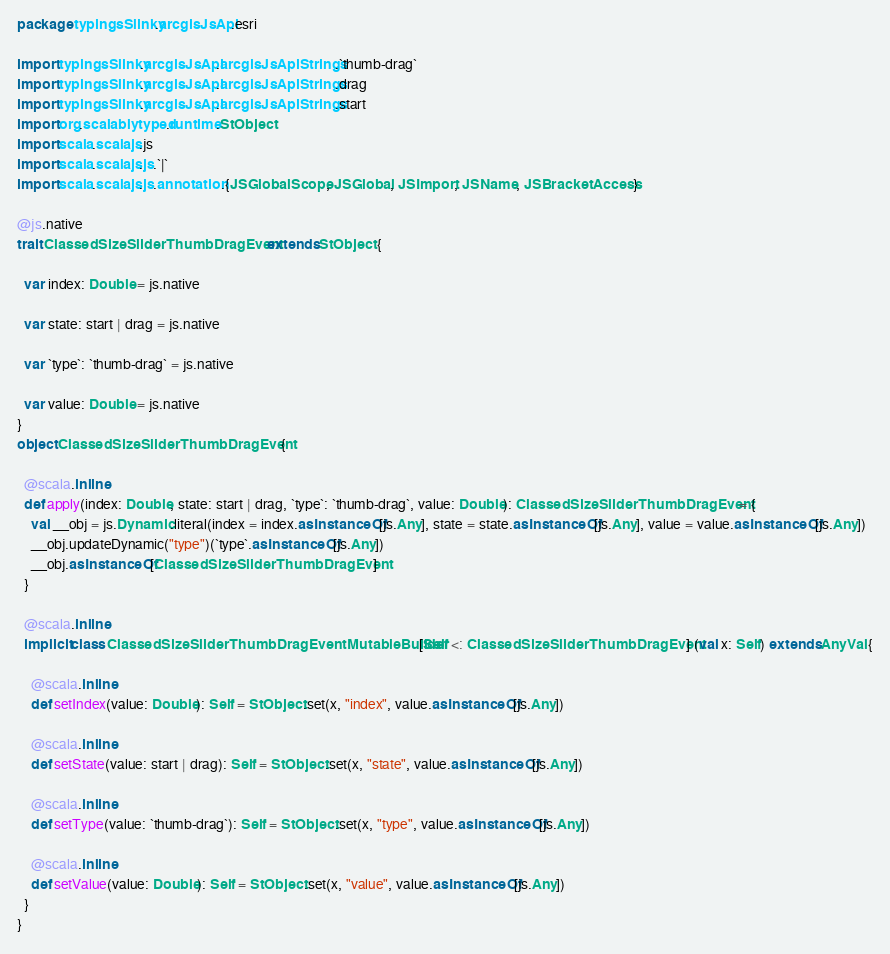<code> <loc_0><loc_0><loc_500><loc_500><_Scala_>package typingsSlinky.arcgisJsApi.esri

import typingsSlinky.arcgisJsApi.arcgisJsApiStrings.`thumb-drag`
import typingsSlinky.arcgisJsApi.arcgisJsApiStrings.drag
import typingsSlinky.arcgisJsApi.arcgisJsApiStrings.start
import org.scalablytyped.runtime.StObject
import scala.scalajs.js
import scala.scalajs.js.`|`
import scala.scalajs.js.annotation.{JSGlobalScope, JSGlobal, JSImport, JSName, JSBracketAccess}

@js.native
trait ClassedSizeSliderThumbDragEvent extends StObject {
  
  var index: Double = js.native
  
  var state: start | drag = js.native
  
  var `type`: `thumb-drag` = js.native
  
  var value: Double = js.native
}
object ClassedSizeSliderThumbDragEvent {
  
  @scala.inline
  def apply(index: Double, state: start | drag, `type`: `thumb-drag`, value: Double): ClassedSizeSliderThumbDragEvent = {
    val __obj = js.Dynamic.literal(index = index.asInstanceOf[js.Any], state = state.asInstanceOf[js.Any], value = value.asInstanceOf[js.Any])
    __obj.updateDynamic("type")(`type`.asInstanceOf[js.Any])
    __obj.asInstanceOf[ClassedSizeSliderThumbDragEvent]
  }
  
  @scala.inline
  implicit class ClassedSizeSliderThumbDragEventMutableBuilder[Self <: ClassedSizeSliderThumbDragEvent] (val x: Self) extends AnyVal {
    
    @scala.inline
    def setIndex(value: Double): Self = StObject.set(x, "index", value.asInstanceOf[js.Any])
    
    @scala.inline
    def setState(value: start | drag): Self = StObject.set(x, "state", value.asInstanceOf[js.Any])
    
    @scala.inline
    def setType(value: `thumb-drag`): Self = StObject.set(x, "type", value.asInstanceOf[js.Any])
    
    @scala.inline
    def setValue(value: Double): Self = StObject.set(x, "value", value.asInstanceOf[js.Any])
  }
}
</code> 